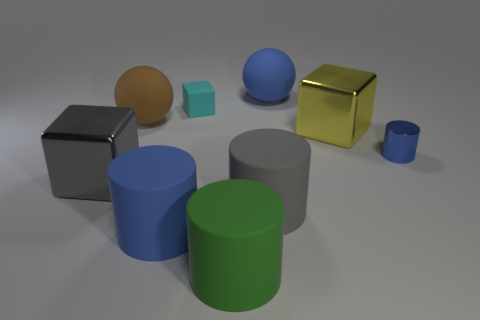Subtract all cyan rubber blocks. How many blocks are left? 2 Add 1 big shiny cubes. How many objects exist? 10 Subtract all yellow blocks. How many blocks are left? 2 Subtract all spheres. How many objects are left? 7 Subtract 2 cylinders. How many cylinders are left? 2 Subtract all gray cylinders. Subtract all gray blocks. How many cylinders are left? 3 Subtract all yellow cubes. How many blue cylinders are left? 2 Subtract all yellow shiny cubes. Subtract all large rubber cylinders. How many objects are left? 5 Add 5 rubber spheres. How many rubber spheres are left? 7 Add 8 gray things. How many gray things exist? 10 